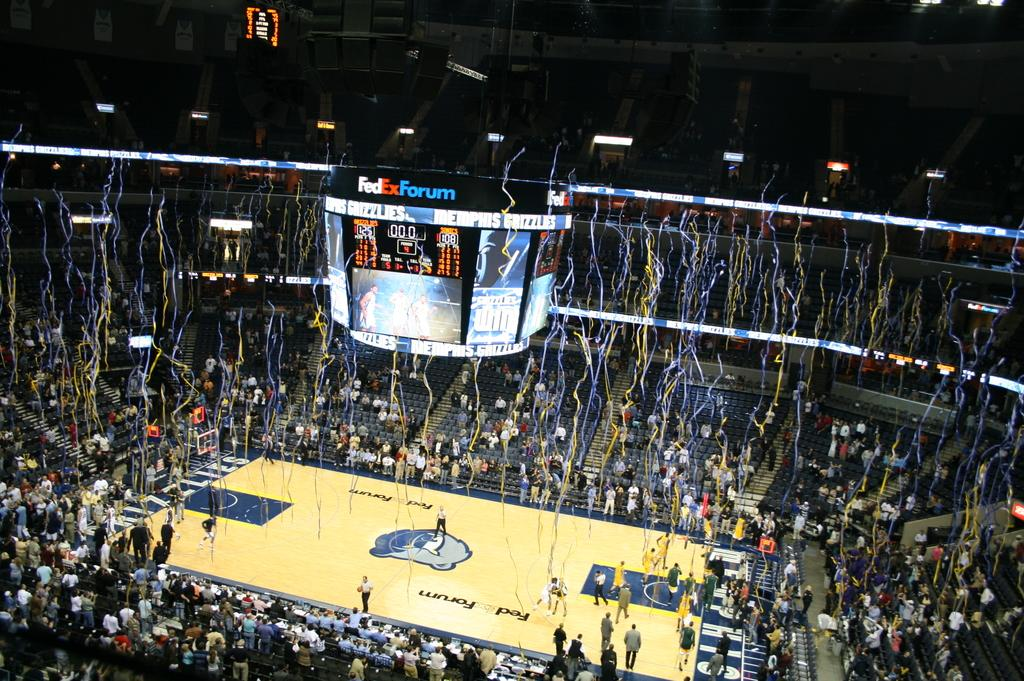Provide a one-sentence caption for the provided image. Victory streamers are falling in a basketball arena where a team won with 125 points. 